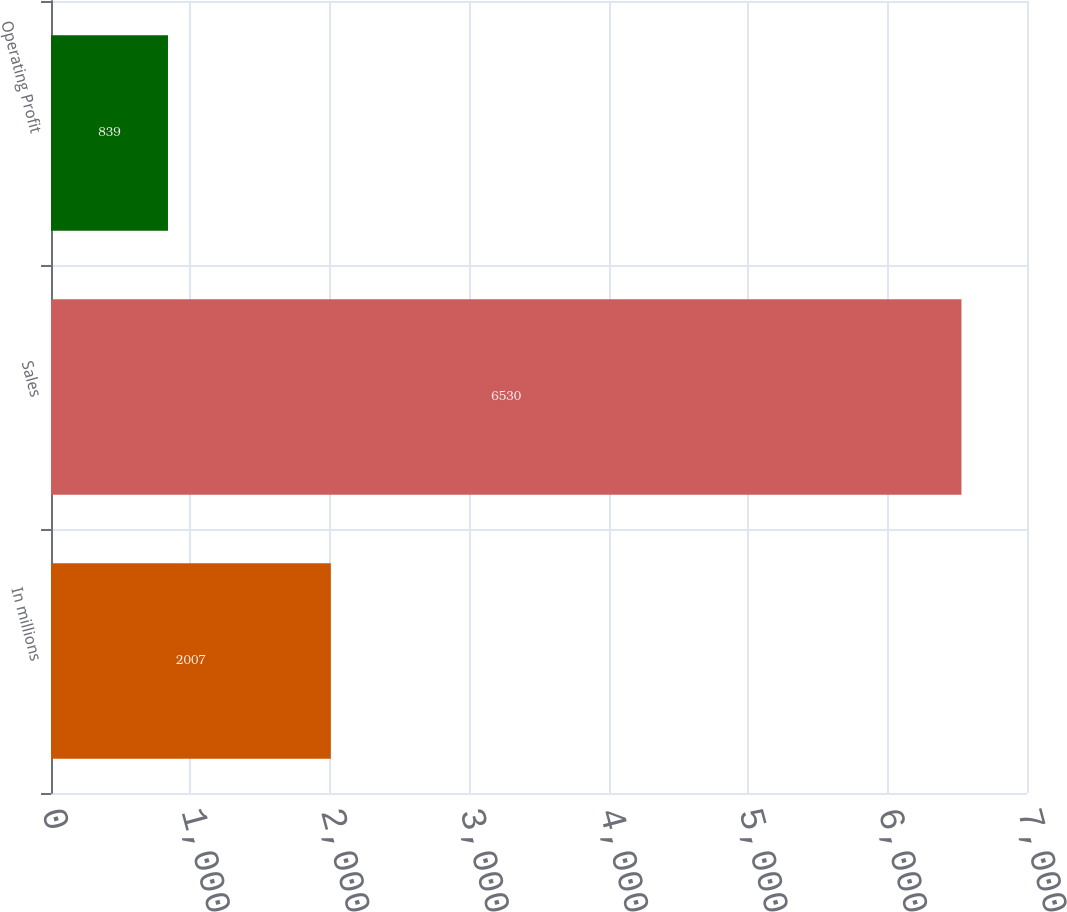<chart> <loc_0><loc_0><loc_500><loc_500><bar_chart><fcel>In millions<fcel>Sales<fcel>Operating Profit<nl><fcel>2007<fcel>6530<fcel>839<nl></chart> 